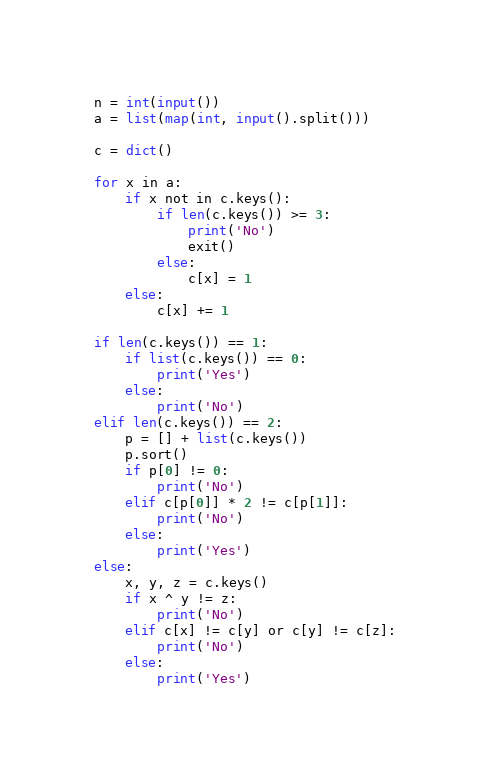Convert code to text. <code><loc_0><loc_0><loc_500><loc_500><_Python_>n = int(input())
a = list(map(int, input().split()))

c = dict()

for x in a:
    if x not in c.keys():
        if len(c.keys()) >= 3:
            print('No')
            exit()
        else:
            c[x] = 1
    else:
        c[x] += 1

if len(c.keys()) == 1:
    if list(c.keys()) == 0:
        print('Yes')
    else:
        print('No')
elif len(c.keys()) == 2:
    p = [] + list(c.keys())
    p.sort()
    if p[0] != 0:
        print('No')
    elif c[p[0]] * 2 != c[p[1]]:
        print('No')
    else:
        print('Yes')
else:
    x, y, z = c.keys()
    if x ^ y != z:
        print('No')
    elif c[x] != c[y] or c[y] != c[z]:
        print('No')
    else:
        print('Yes')</code> 